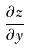<formula> <loc_0><loc_0><loc_500><loc_500>\frac { \partial z } { \partial y }</formula> 